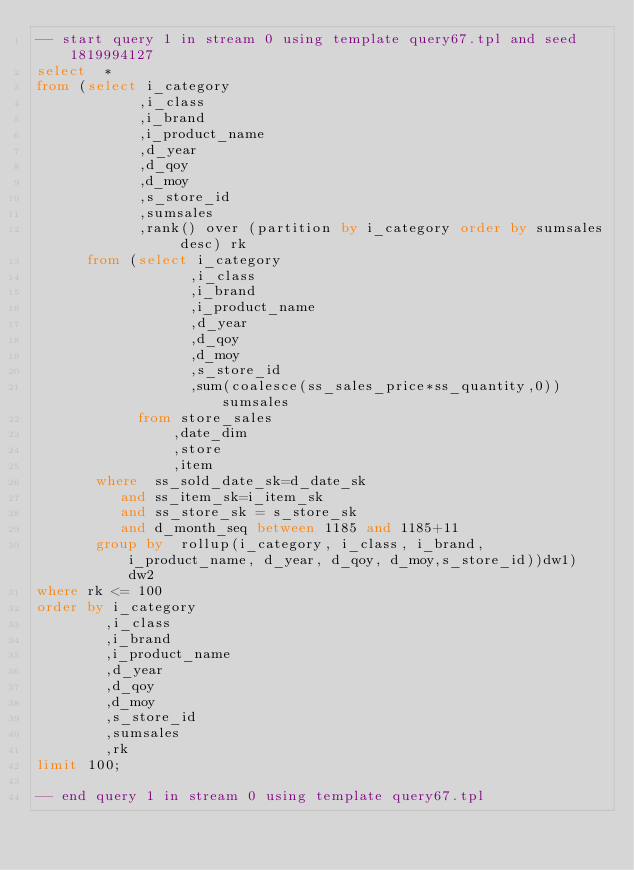Convert code to text. <code><loc_0><loc_0><loc_500><loc_500><_SQL_>-- start query 1 in stream 0 using template query67.tpl and seed 1819994127
select  *
from (select i_category
            ,i_class
            ,i_brand
            ,i_product_name
            ,d_year
            ,d_qoy
            ,d_moy
            ,s_store_id
            ,sumsales
            ,rank() over (partition by i_category order by sumsales desc) rk
      from (select i_category
                  ,i_class
                  ,i_brand
                  ,i_product_name
                  ,d_year
                  ,d_qoy
                  ,d_moy
                  ,s_store_id
                  ,sum(coalesce(ss_sales_price*ss_quantity,0)) sumsales
            from store_sales
                ,date_dim
                ,store
                ,item
       where  ss_sold_date_sk=d_date_sk
          and ss_item_sk=i_item_sk
          and ss_store_sk = s_store_sk
          and d_month_seq between 1185 and 1185+11
       group by  rollup(i_category, i_class, i_brand, i_product_name, d_year, d_qoy, d_moy,s_store_id))dw1) dw2
where rk <= 100
order by i_category
        ,i_class
        ,i_brand
        ,i_product_name
        ,d_year
        ,d_qoy
        ,d_moy
        ,s_store_id
        ,sumsales
        ,rk
limit 100;

-- end query 1 in stream 0 using template query67.tpl
</code> 